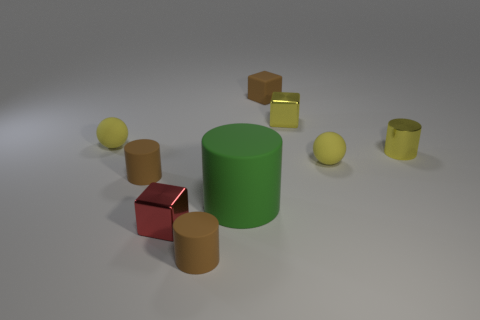Subtract all blocks. How many objects are left? 6 Subtract 0 cyan spheres. How many objects are left? 9 Subtract all big cyan metal spheres. Subtract all yellow cylinders. How many objects are left? 8 Add 4 tiny brown cylinders. How many tiny brown cylinders are left? 6 Add 8 big green rubber cylinders. How many big green rubber cylinders exist? 9 